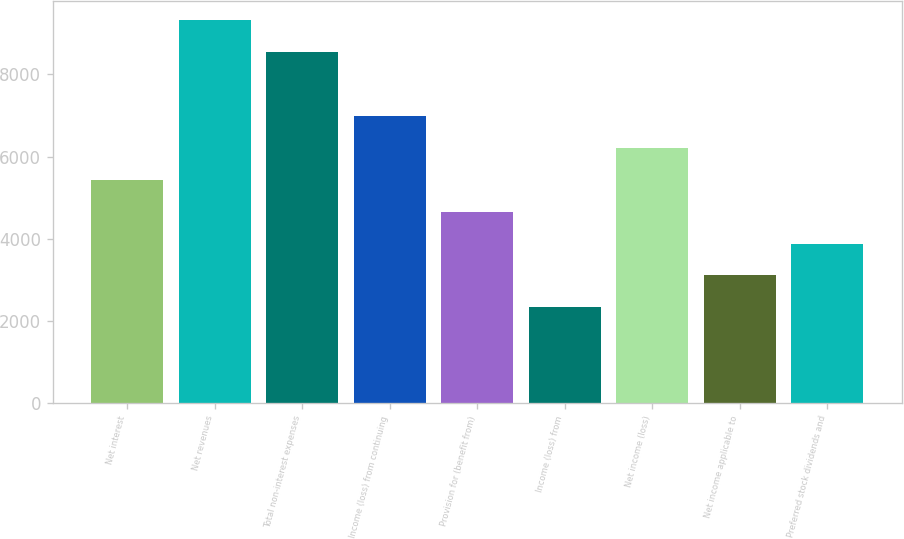Convert chart. <chart><loc_0><loc_0><loc_500><loc_500><bar_chart><fcel>Net interest<fcel>Net revenues<fcel>Total non-interest expenses<fcel>Income (loss) from continuing<fcel>Provision for (benefit from)<fcel>Income (loss) from<fcel>Net income (loss)<fcel>Net income applicable to<fcel>Preferred stock dividends and<nl><fcel>5436.97<fcel>9320.41<fcel>8543.73<fcel>6990.35<fcel>4660.28<fcel>2330.22<fcel>6213.66<fcel>3106.9<fcel>3883.59<nl></chart> 